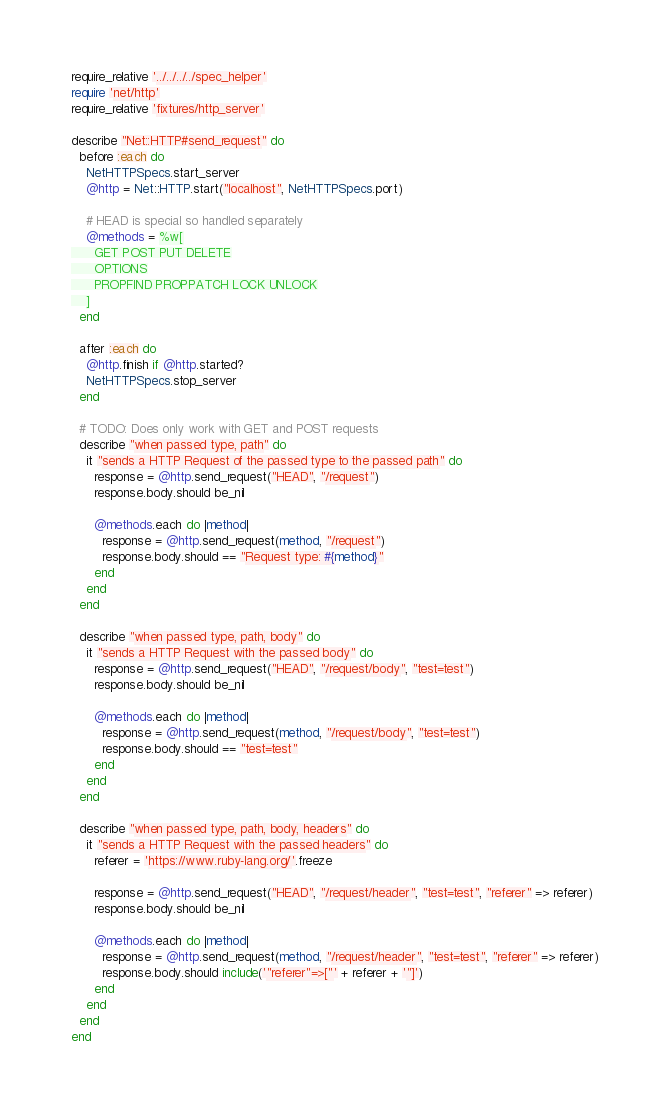<code> <loc_0><loc_0><loc_500><loc_500><_Ruby_>require_relative '../../../../spec_helper'
require 'net/http'
require_relative 'fixtures/http_server'

describe "Net::HTTP#send_request" do
  before :each do
    NetHTTPSpecs.start_server
    @http = Net::HTTP.start("localhost", NetHTTPSpecs.port)

    # HEAD is special so handled separately
    @methods = %w[
      GET POST PUT DELETE
      OPTIONS
      PROPFIND PROPPATCH LOCK UNLOCK
    ]
  end

  after :each do
    @http.finish if @http.started?
    NetHTTPSpecs.stop_server
  end

  # TODO: Does only work with GET and POST requests
  describe "when passed type, path" do
    it "sends a HTTP Request of the passed type to the passed path" do
      response = @http.send_request("HEAD", "/request")
      response.body.should be_nil

      @methods.each do |method|
        response = @http.send_request(method, "/request")
        response.body.should == "Request type: #{method}"
      end
    end
  end

  describe "when passed type, path, body" do
    it "sends a HTTP Request with the passed body" do
      response = @http.send_request("HEAD", "/request/body", "test=test")
      response.body.should be_nil

      @methods.each do |method|
        response = @http.send_request(method, "/request/body", "test=test")
        response.body.should == "test=test"
      end
    end
  end

  describe "when passed type, path, body, headers" do
    it "sends a HTTP Request with the passed headers" do
      referer = 'https://www.ruby-lang.org/'.freeze

      response = @http.send_request("HEAD", "/request/header", "test=test", "referer" => referer)
      response.body.should be_nil

      @methods.each do |method|
        response = @http.send_request(method, "/request/header", "test=test", "referer" => referer)
        response.body.should include('"referer"=>["' + referer + '"]')
      end
    end
  end
end
</code> 